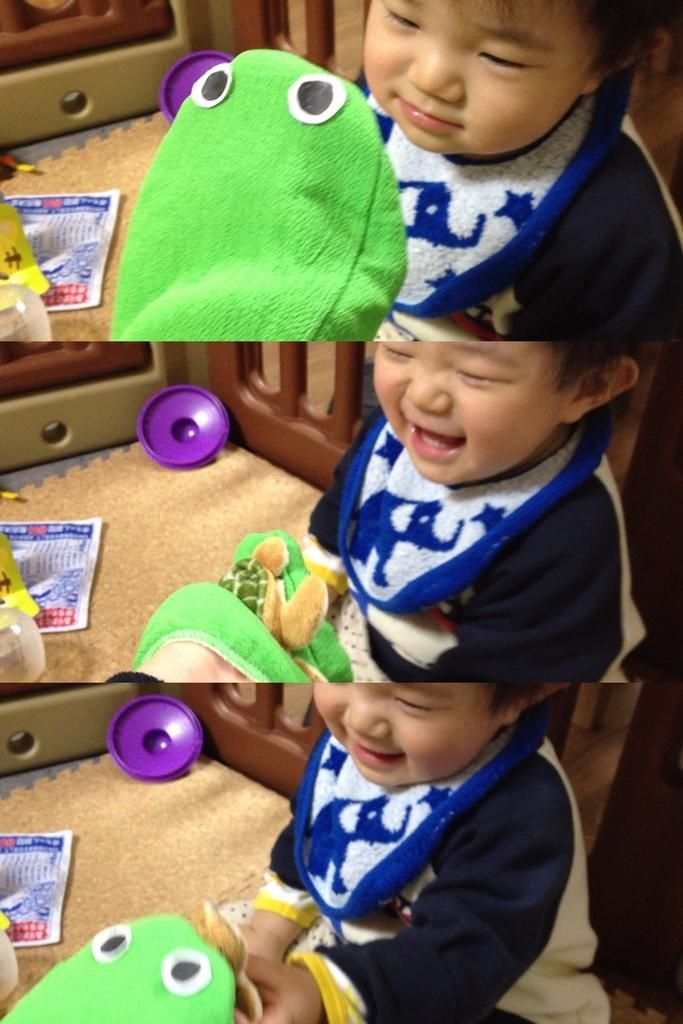What type of artwork is the image? The image is a collage. Can you identify any living beings in the image? Yes, there is a person in the image. What other objects can be seen in the image? There is a toy, cloth on the ground, and objects on the ground visible in the image. What is the setting of the image? The ground and a background are visible in the image. Are there any objects in the background? Yes, there is an object in the background. How many spiders are crawling on the person in the image? There are no spiders visible in the image; it only features a person, a toy, cloth, objects on the ground, and a background with an object. 